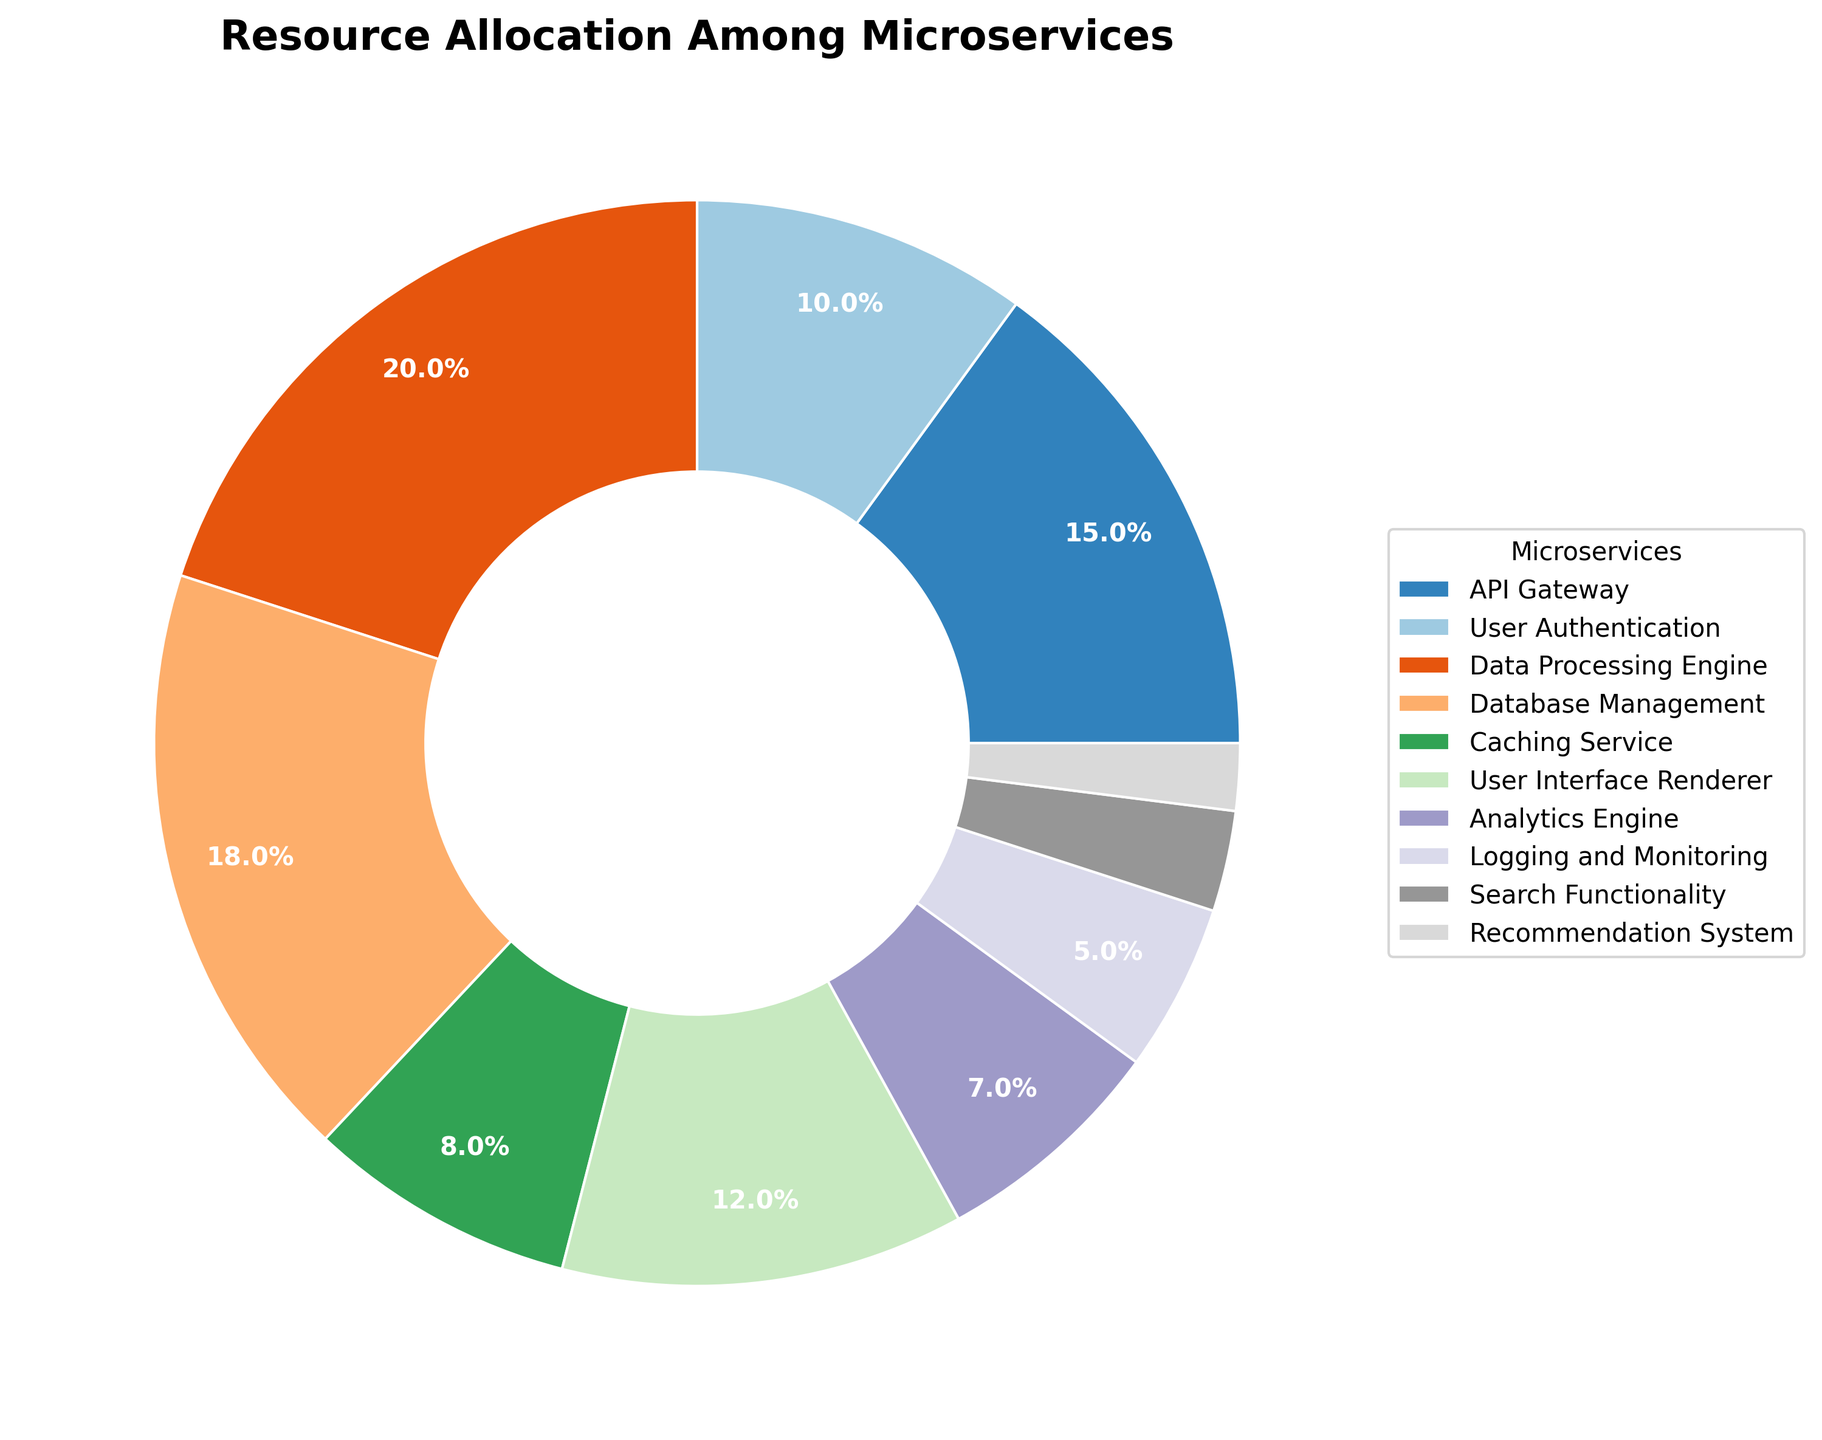Which microservice has the largest resource allocation? The pie chart shows different slices representing each microservice and their allocated resources. The largest slice visually belongs to the Data Processing Engine.
Answer: Data Processing Engine Which microservice allocates more resources, the API Gateway or the User Interface Renderer? By comparing the sizes of the slices, we can see that the API Gateway (15%) has a larger slice than the User Interface Renderer (12%).
Answer: API Gateway What is the total percentage of resources allocated to the User Interface Renderer and the Caching Service? By adding the resource allocations for the User Interface Renderer (12%) and the Caching Service (8%), we get 12% + 8% = 20%.
Answer: 20% How much more resource allocation does the Database Management have compared to the Analytics Engine? The Database Management has an allocation of 18%, and the Analytics Engine has 7%. The difference is 18% - 7% = 11%.
Answer: 11% Which microservice receives the least allocation of resources? The smallest slice in the pie chart represents the Recommendation System, which has a resource allocation of 2%.
Answer: Recommendation System Are there any microservices that have less than 5% resource allocation? If so, which ones? The microservices with resource allocations less than 5% are represented by small slices. The ones below 5% are Search Functionality (3%) and Recommendation System (2%).
Answer: Search Functionality, Recommendation System What is the combined resource allocation percentage for microservices that manage user-related functionalities (User Authentication + User Interface Renderer)? Adding the percentages for User Authentication (10%) and User Interface Renderer (12%) gives 10% + 12% = 22%.
Answer: 22% What percentage of system resources is allocated to non-user facing services (Data Processing Engine, Database Management, Caching Service, Logging and Monitoring, Recommendation System)? Summing the resource allocations: Data Processing Engine (20%) + Database Management (18%) + Caching Service (8%) + Logging and Monitoring (5%) + Recommendation System (2%) = 20% + 18% + 8% + 5% + 2% = 53%.
Answer: 53% Which microservice has a resource allocation closest to 10%? By inspecting the pie chart, the User Authentication service has an allocation of exactly 10%.
Answer: User Authentication 